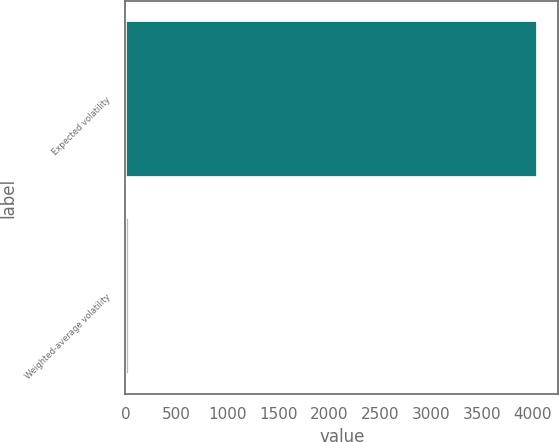Convert chart to OTSL. <chart><loc_0><loc_0><loc_500><loc_500><bar_chart><fcel>Expected volatility<fcel>Weighted-average volatility<nl><fcel>4048<fcel>45<nl></chart> 